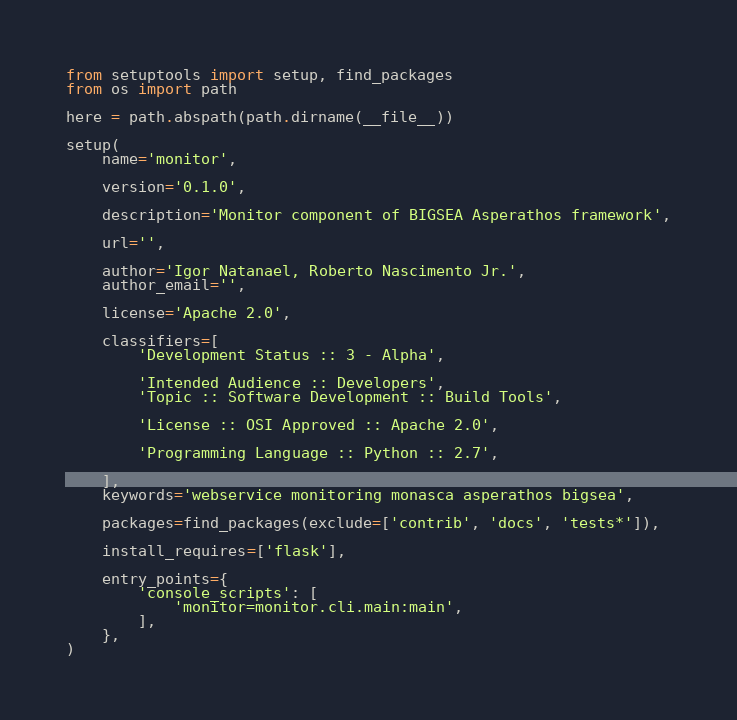<code> <loc_0><loc_0><loc_500><loc_500><_Python_>from setuptools import setup, find_packages
from os import path

here = path.abspath(path.dirname(__file__))

setup(
    name='monitor',

    version='0.1.0',

    description='Monitor component of BIGSEA Asperathos framework',

    url='',

    author='Igor Natanael, Roberto Nascimento Jr.',
    author_email='',

    license='Apache 2.0',

    classifiers=[
        'Development Status :: 3 - Alpha',

        'Intended Audience :: Developers',
        'Topic :: Software Development :: Build Tools',

        'License :: OSI Approved :: Apache 2.0',

        'Programming Language :: Python :: 2.7',

    ],
    keywords='webservice monitoring monasca asperathos bigsea',

    packages=find_packages(exclude=['contrib', 'docs', 'tests*']),

    install_requires=['flask'],

    entry_points={
        'console_scripts': [
            'monitor=monitor.cli.main:main',
        ],
    },
)

</code> 